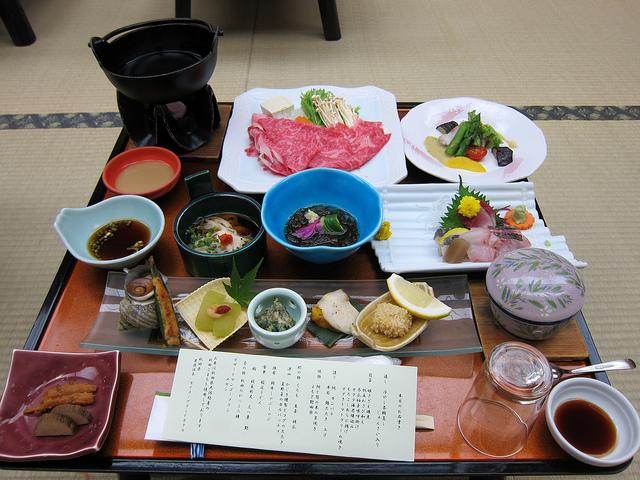What type of food is this?
Keep it brief. Asian. What is red that is placed on the plate?
Keep it brief. Meat. Is the bill in English?
Give a very brief answer. No. 